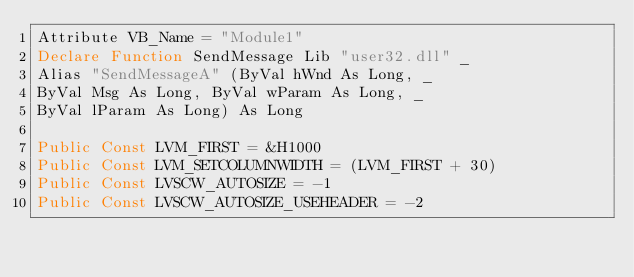Convert code to text. <code><loc_0><loc_0><loc_500><loc_500><_VisualBasic_>Attribute VB_Name = "Module1"
Declare Function SendMessage Lib "user32.dll" _
Alias "SendMessageA" (ByVal hWnd As Long, _
ByVal Msg As Long, ByVal wParam As Long, _
ByVal lParam As Long) As Long

Public Const LVM_FIRST = &H1000
Public Const LVM_SETCOLUMNWIDTH = (LVM_FIRST + 30)
Public Const LVSCW_AUTOSIZE = -1
Public Const LVSCW_AUTOSIZE_USEHEADER = -2


</code> 